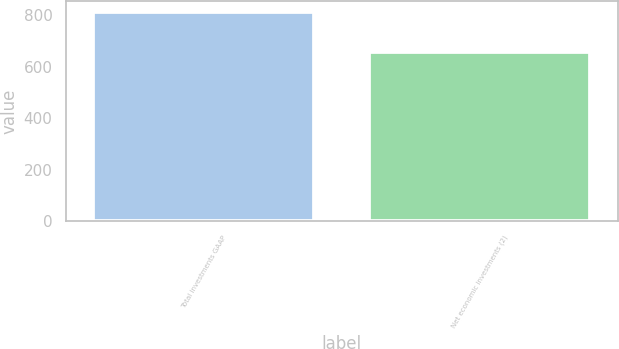Convert chart. <chart><loc_0><loc_0><loc_500><loc_500><bar_chart><fcel>Total investments GAAP<fcel>Net economic investments (2)<nl><fcel>813<fcel>656<nl></chart> 